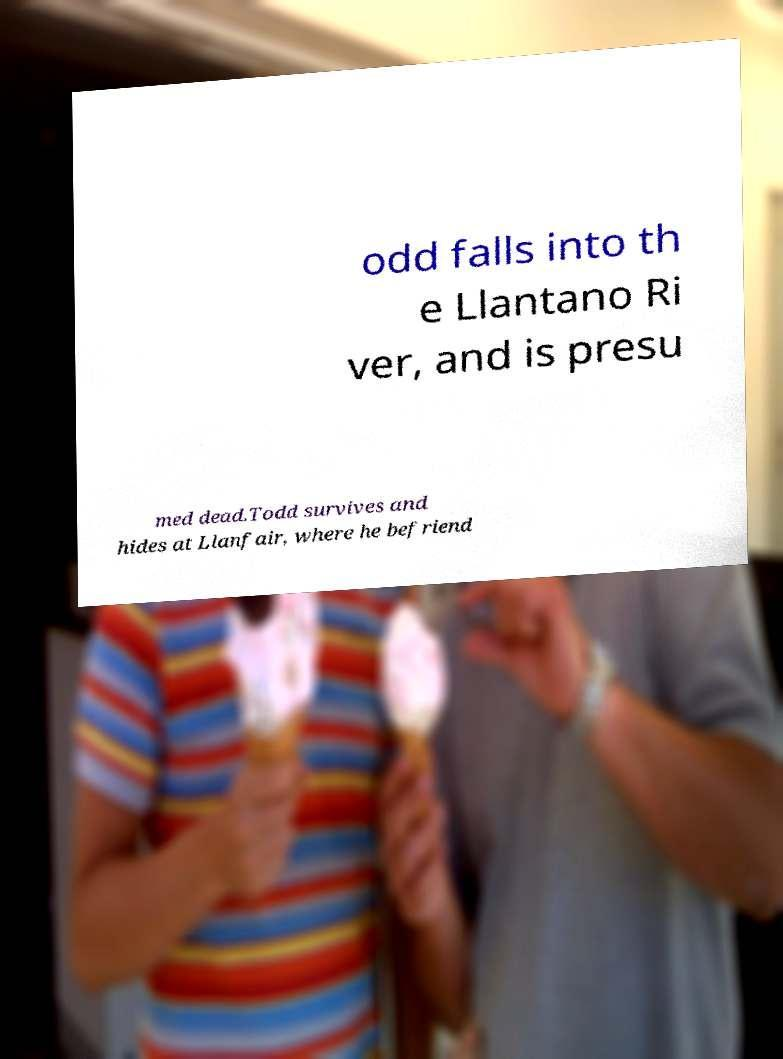Could you extract and type out the text from this image? odd falls into th e Llantano Ri ver, and is presu med dead.Todd survives and hides at Llanfair, where he befriend 